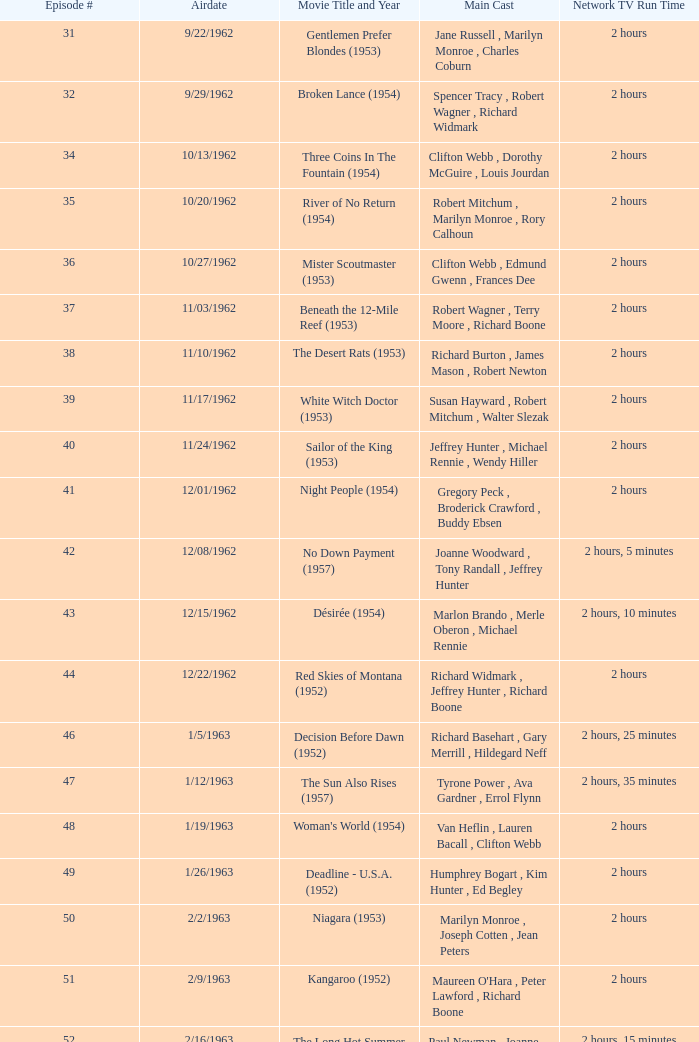In which film did dana wynter, mel ferrer, and theodore bikel appear together? Fraulein (1958). 